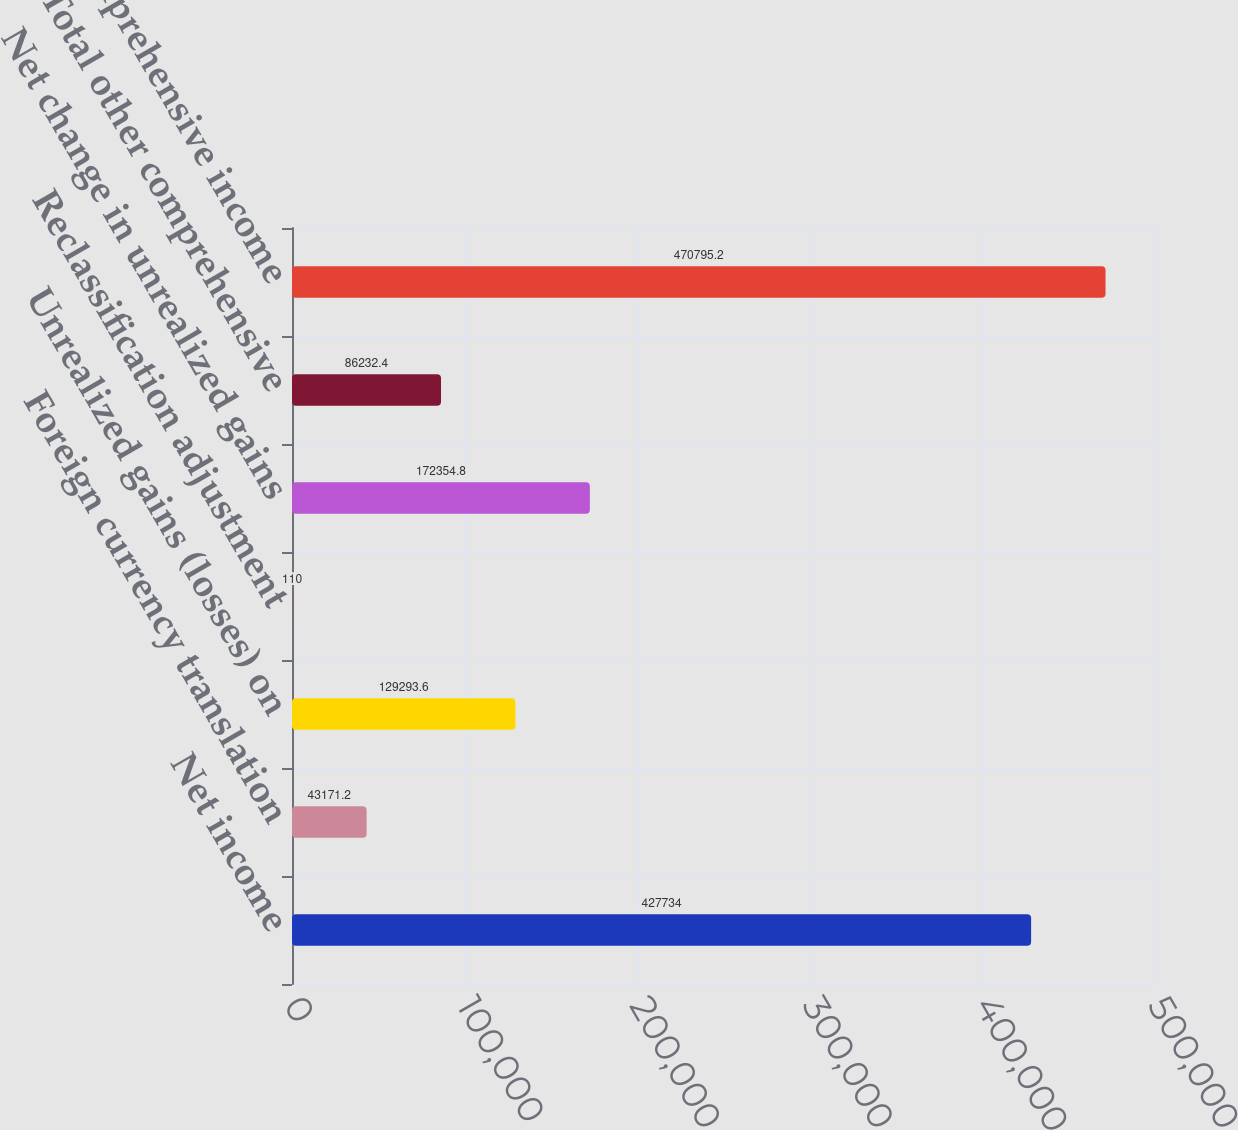Convert chart. <chart><loc_0><loc_0><loc_500><loc_500><bar_chart><fcel>Net income<fcel>Foreign currency translation<fcel>Unrealized gains (losses) on<fcel>Reclassification adjustment<fcel>Net change in unrealized gains<fcel>Total other comprehensive<fcel>Comprehensive income<nl><fcel>427734<fcel>43171.2<fcel>129294<fcel>110<fcel>172355<fcel>86232.4<fcel>470795<nl></chart> 